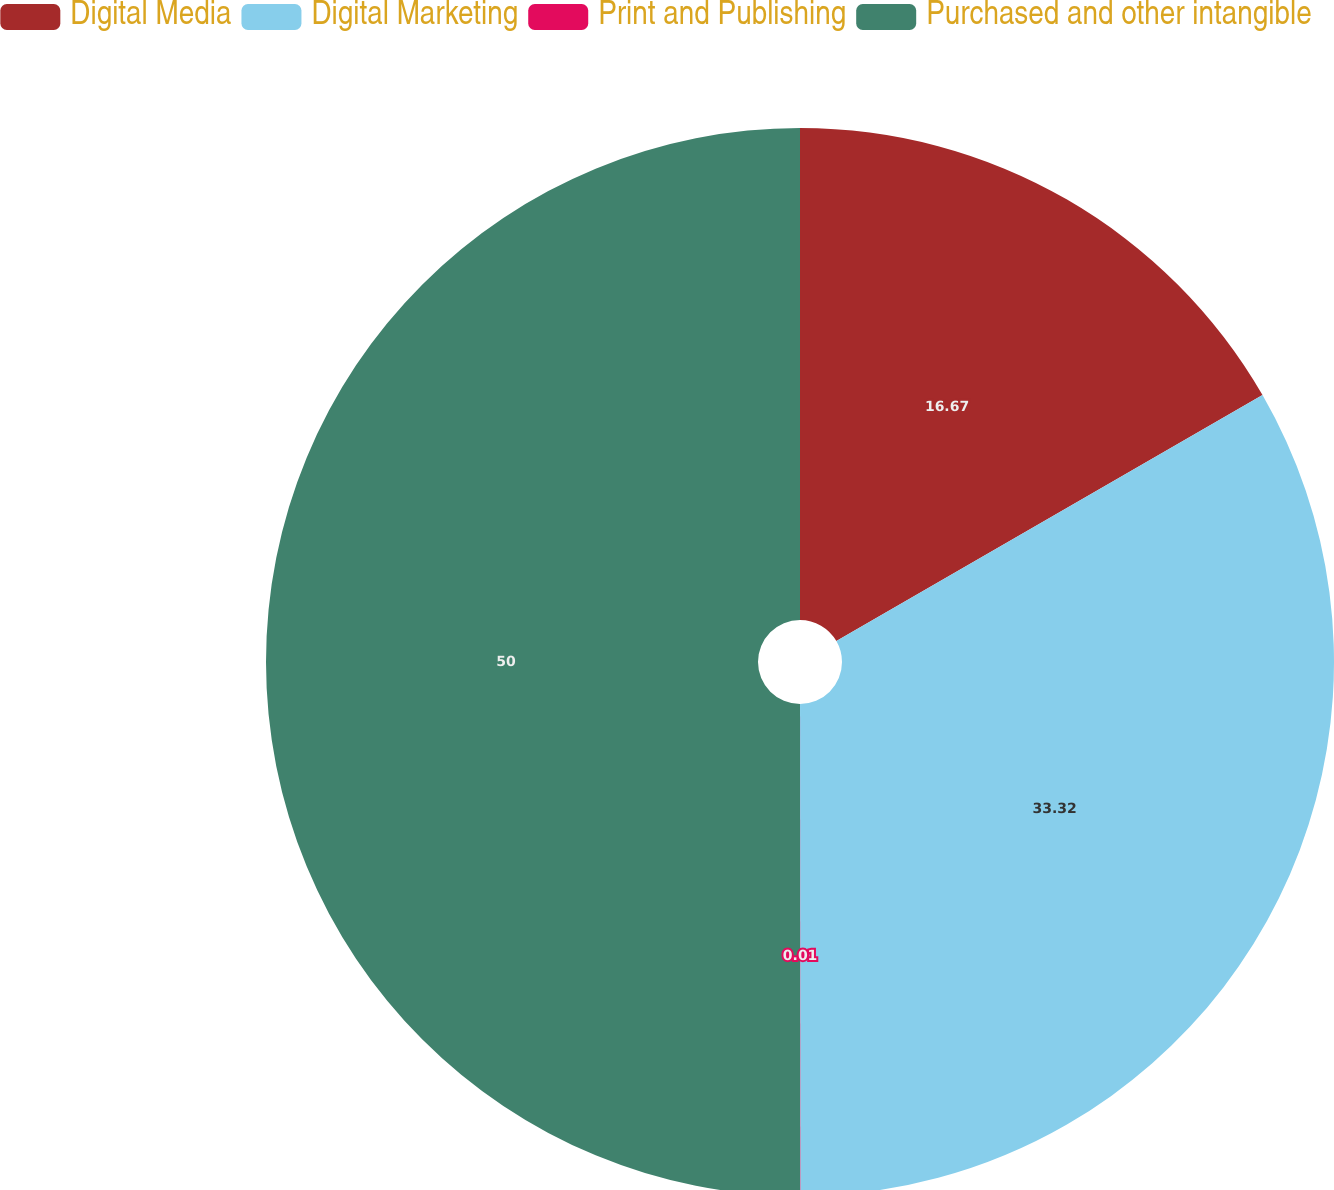Convert chart to OTSL. <chart><loc_0><loc_0><loc_500><loc_500><pie_chart><fcel>Digital Media<fcel>Digital Marketing<fcel>Print and Publishing<fcel>Purchased and other intangible<nl><fcel>16.67%<fcel>33.32%<fcel>0.01%<fcel>50.0%<nl></chart> 